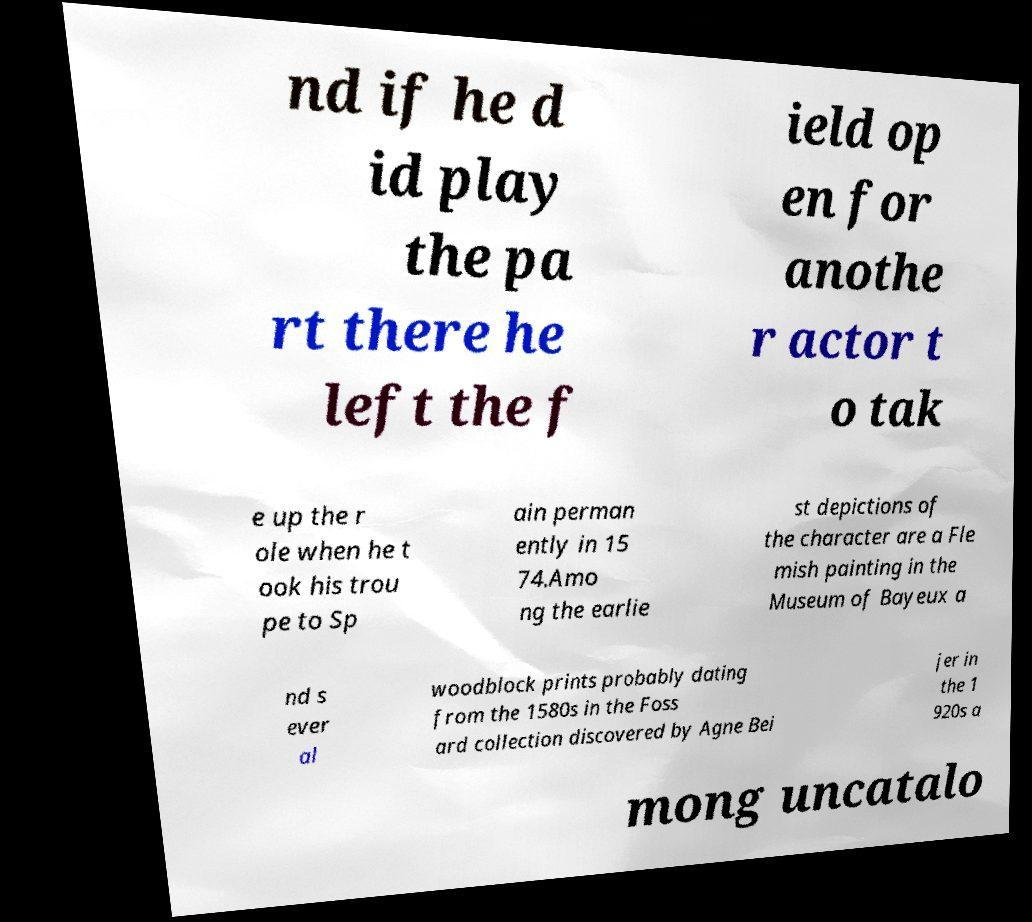For documentation purposes, I need the text within this image transcribed. Could you provide that? nd if he d id play the pa rt there he left the f ield op en for anothe r actor t o tak e up the r ole when he t ook his trou pe to Sp ain perman ently in 15 74.Amo ng the earlie st depictions of the character are a Fle mish painting in the Museum of Bayeux a nd s ever al woodblock prints probably dating from the 1580s in the Foss ard collection discovered by Agne Bei jer in the 1 920s a mong uncatalo 